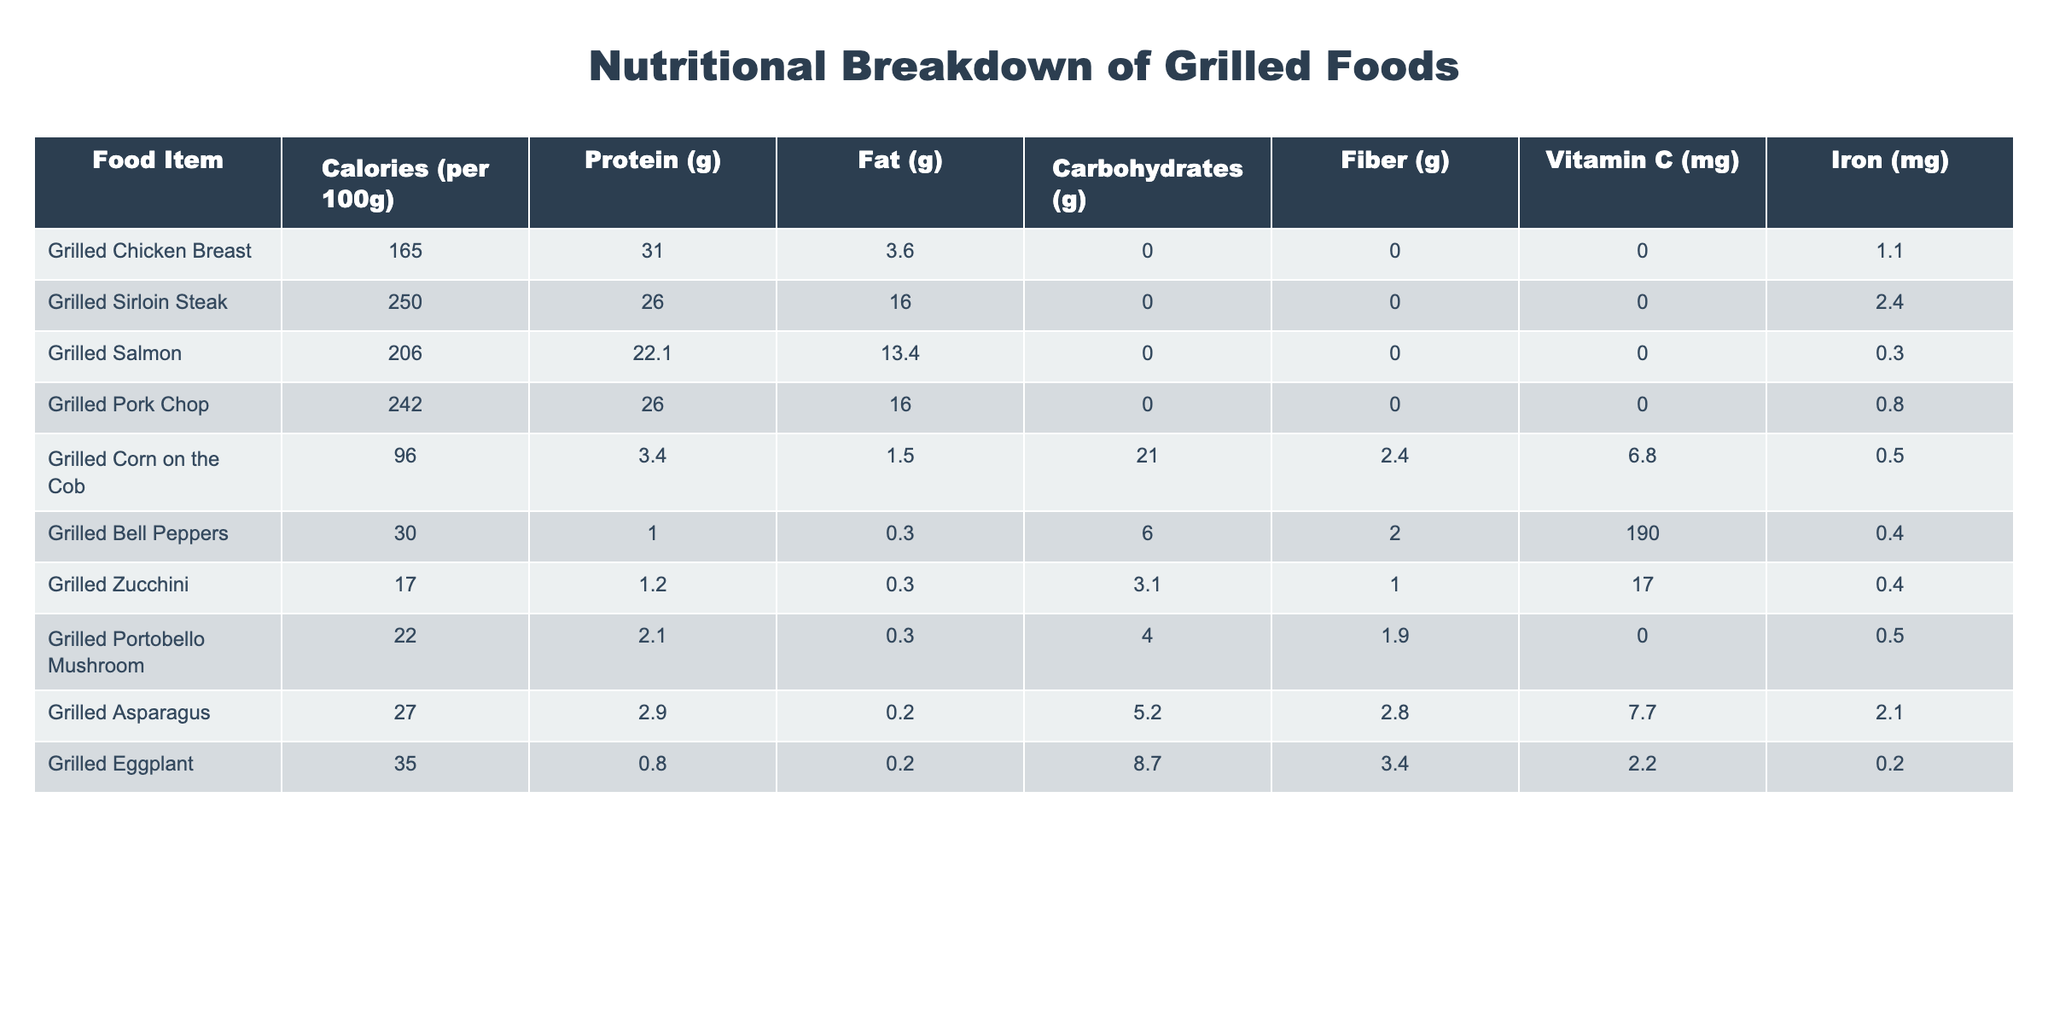What is the calorie content of grilled chicken breast? The table lists the calorie content of grilled chicken breast, which is provided as 165 calories per 100g.
Answer: 165 calories Which grilled item has the highest protein content? By examining the protein values, grilled chicken breast has 31g, while other meats, like grilled pork chop, has 26g. Therefore, grilled chicken breast has the highest protein content.
Answer: Grilled chicken breast How many grams of fat are in grilled salmon? The table shows that grilled salmon contains 13.4g of fat per 100g.
Answer: 13.4g What is the total carbohydrate content of grilled corn on the cob and grilled zucchini? The carbohydrate content for grilled corn on the cob is 21g and for grilled zucchini is 3.1g; adding these values gives 21 + 3.1 = 24.1g.
Answer: 24.1g Is grilled asparagus high in vitamin C? Grilled asparagus contains 7.7mg of vitamin C, which is relatively low compared to other vegetables, but it is still a source of vitamin C.
Answer: Yes, but relatively low What is the difference in iron content between grilled sirloin steak and grilled pork chop? Grilled sirloin steak contains 2.4mg of iron, while grilled pork chop contains 0.8mg; the difference is 2.4 - 0.8 = 1.6mg.
Answer: 1.6mg What is the average calorie content of the grilled vegetables listed? The grilled vegetables listed are grilled corn (96), bell peppers (30), zucchini (17), portobello mushroom (22), asparagus (27), and eggplant (35). The average is (96 + 30 + 17 + 22 + 27 + 35) / 6 = 229 / 6 = 38.17, rounded as necessary.
Answer: Approximately 38.17 calories Which grilled meat has the highest fat content, and what is that value? Analyzing the table shows grilled sirloin steak and grilled pork chop both have 16g of fat, which is the highest among the listed meats.
Answer: Grilled sirloin steak and grilled pork chop with 16g How much fiber is found in grilled corn on the cob? The table indicates that grilled corn on the cob has 2.4g of fiber per 100g serving.
Answer: 2.4g If a person wanted to consume only grilled vegetables, which option would provide the most vitamin C? Comparing the vitamin C content of grilled bell peppers (190mg) and other vegetables, they have the highest at 190mg.
Answer: Grilled bell peppers with 190mg 